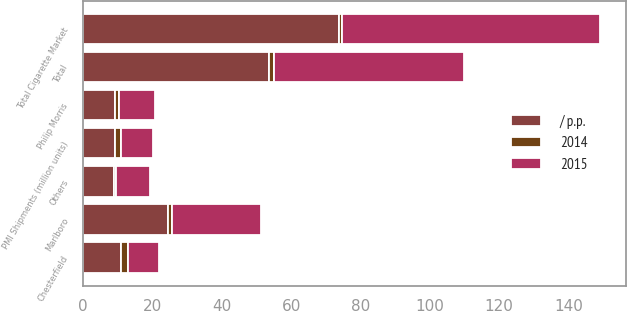Convert chart. <chart><loc_0><loc_0><loc_500><loc_500><stacked_bar_chart><ecel><fcel>Total Cigarette Market<fcel>PMI Shipments (million units)<fcel>Marlboro<fcel>Chesterfield<fcel>Philip Morris<fcel>Others<fcel>Total<nl><fcel>/ p.p.<fcel>73.8<fcel>9.2<fcel>24.6<fcel>11<fcel>9.2<fcel>8.9<fcel>53.7<nl><fcel>2015<fcel>74.4<fcel>9.2<fcel>25.7<fcel>9.2<fcel>10.4<fcel>9.6<fcel>54.9<nl><fcel>2014<fcel>0.8<fcel>1.8<fcel>1.1<fcel>1.8<fcel>1.2<fcel>0.7<fcel>1.2<nl></chart> 